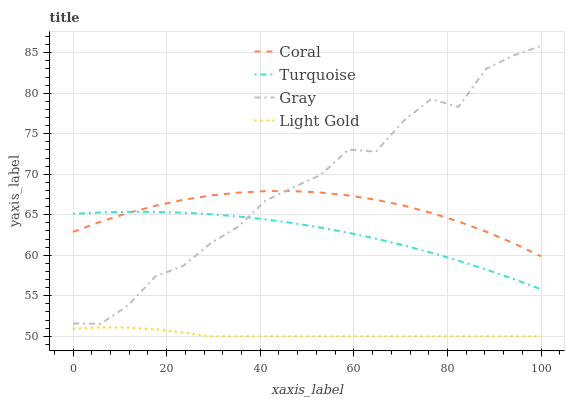Does Light Gold have the minimum area under the curve?
Answer yes or no. Yes. Does Gray have the maximum area under the curve?
Answer yes or no. Yes. Does Coral have the minimum area under the curve?
Answer yes or no. No. Does Coral have the maximum area under the curve?
Answer yes or no. No. Is Light Gold the smoothest?
Answer yes or no. Yes. Is Gray the roughest?
Answer yes or no. Yes. Is Coral the smoothest?
Answer yes or no. No. Is Coral the roughest?
Answer yes or no. No. Does Coral have the lowest value?
Answer yes or no. No. Does Gray have the highest value?
Answer yes or no. Yes. Does Coral have the highest value?
Answer yes or no. No. Is Light Gold less than Turquoise?
Answer yes or no. Yes. Is Gray greater than Light Gold?
Answer yes or no. Yes. Does Gray intersect Turquoise?
Answer yes or no. Yes. Is Gray less than Turquoise?
Answer yes or no. No. Is Gray greater than Turquoise?
Answer yes or no. No. Does Light Gold intersect Turquoise?
Answer yes or no. No. 